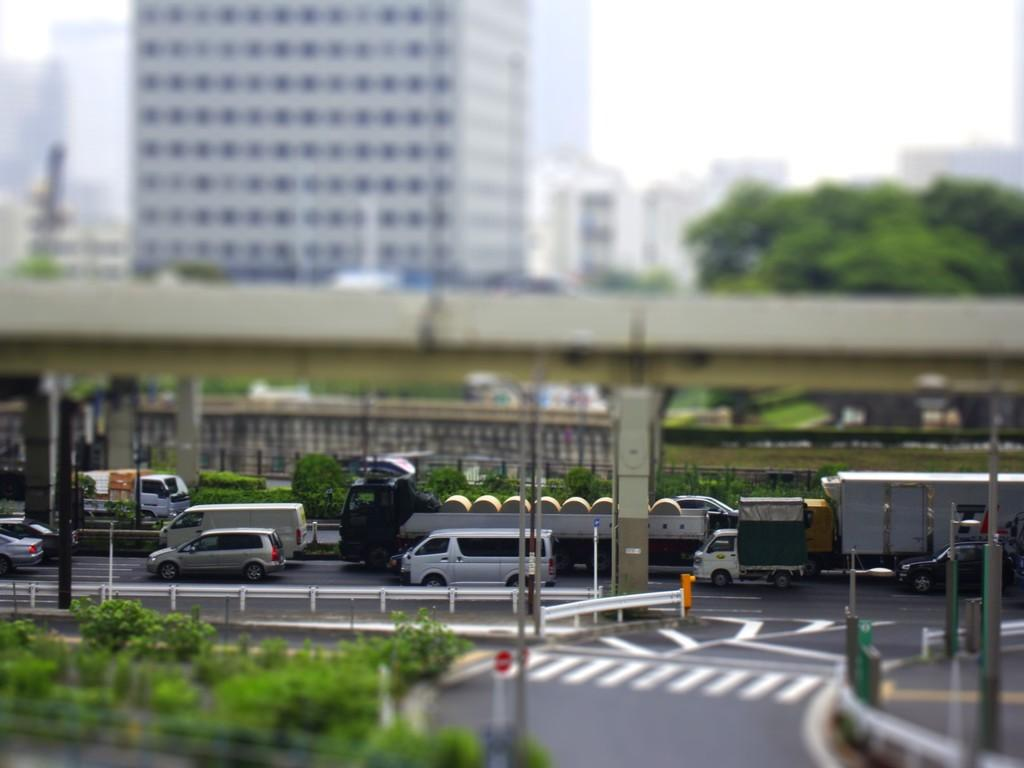What is the appearance of the background in the image? The background portion of the picture is blurred. What can be seen in the sky in the image? There is sky visible in the image. What type of structures are present in the image? There are buildings in the image. Can you identify any natural elements in the image? Yes, there are trees in the image. What is the main subject of the image? This is a bridge. Are there any vehicles in the image? Yes, there are vehicles on the road in the image. What else can be seen in the image besides the bridge and vehicles? There are poles and plants in the image. What type of plants are being exchanged on the canvas in the image? There is no canvas or plant exchange present in the image. 